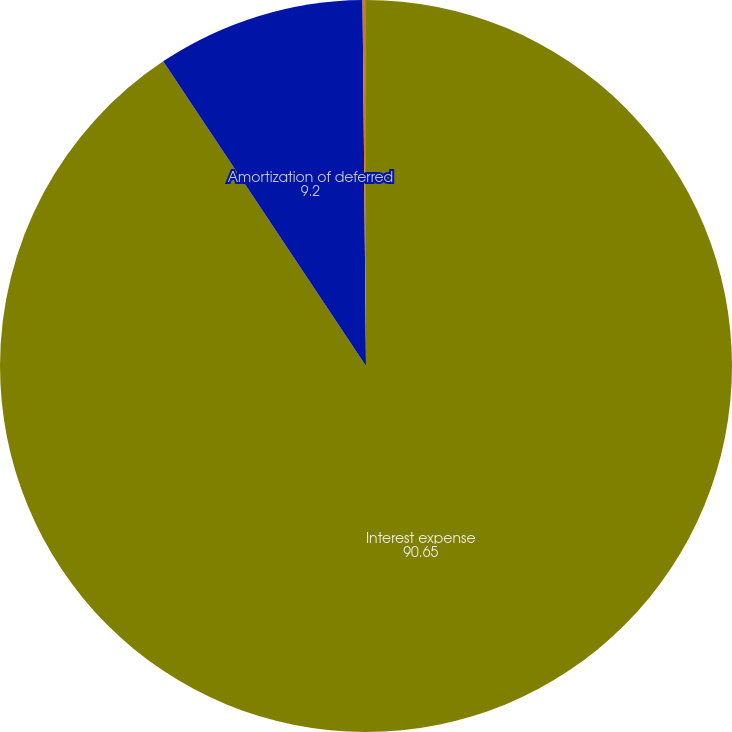Convert chart. <chart><loc_0><loc_0><loc_500><loc_500><pie_chart><fcel>Interest expense<fcel>Amortization of deferred<fcel>Capitalized interest<nl><fcel>90.65%<fcel>9.2%<fcel>0.15%<nl></chart> 